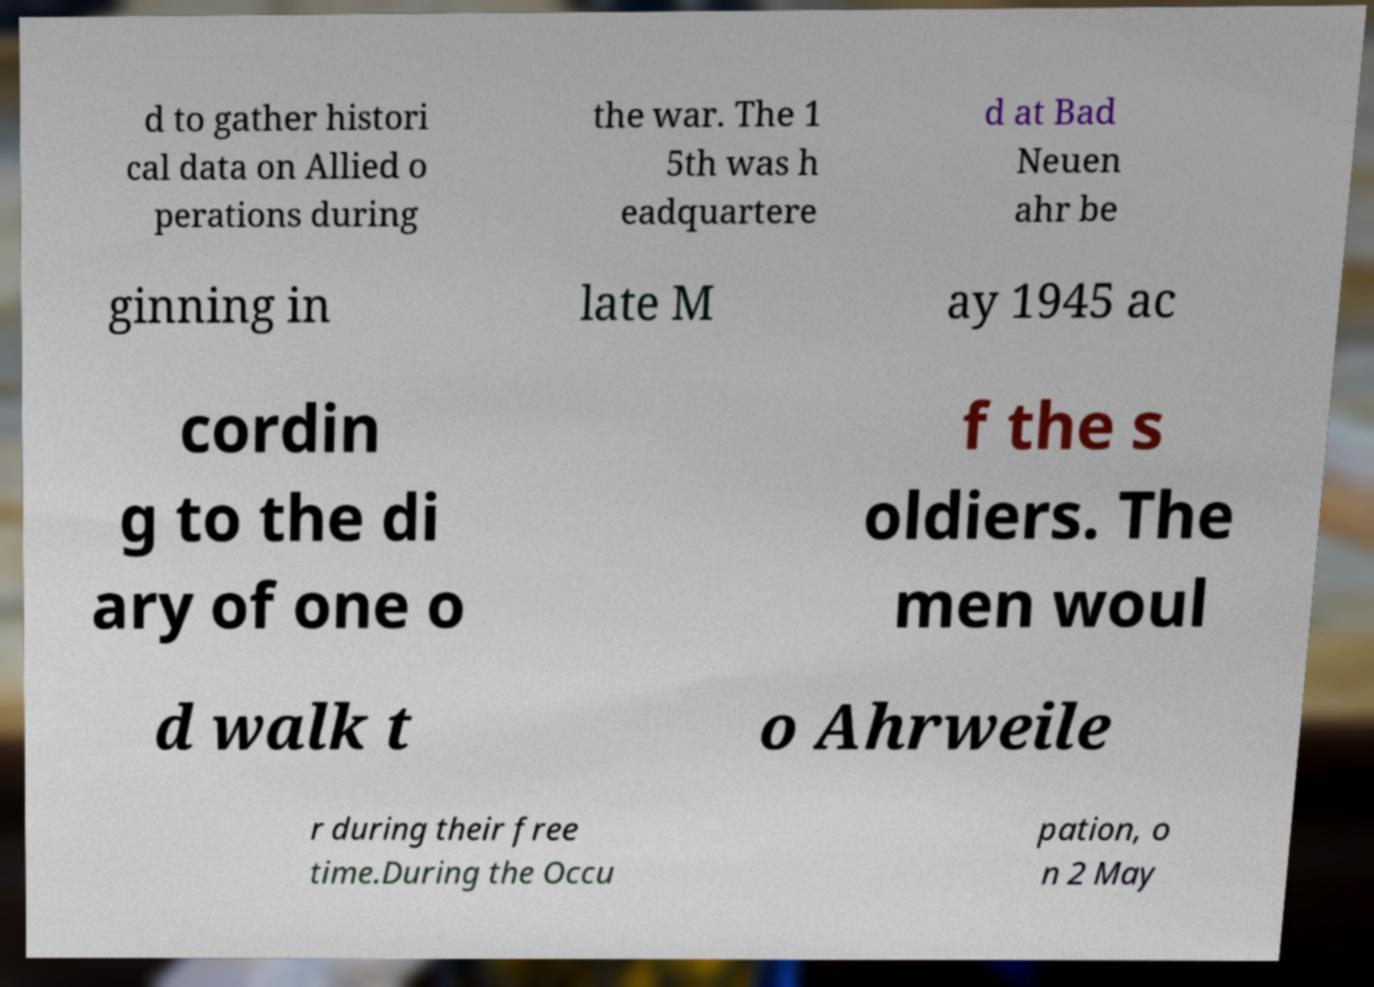Please read and relay the text visible in this image. What does it say? d to gather histori cal data on Allied o perations during the war. The 1 5th was h eadquartere d at Bad Neuen ahr be ginning in late M ay 1945 ac cordin g to the di ary of one o f the s oldiers. The men woul d walk t o Ahrweile r during their free time.During the Occu pation, o n 2 May 